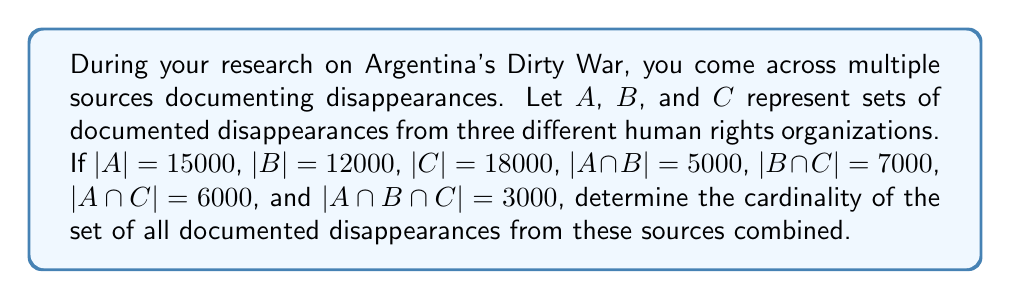What is the answer to this math problem? To solve this problem, we'll use the Inclusion-Exclusion Principle for three sets:

$$|A \cup B \cup C| = |A| + |B| + |C| - |A \cap B| - |B \cap C| - |A \cap C| + |A \cap B \cap C|$$

Let's substitute the given values:

1) $|A| = 15000$
2) $|B| = 12000$
3) $|C| = 18000$
4) $|A \cap B| = 5000$
5) $|B \cap C| = 7000$
6) $|A \cap C| = 6000$
7) $|A \cap B \cap C| = 3000$

Now, let's calculate:

$$\begin{align*}
|A \cup B \cup C| &= 15000 + 12000 + 18000 - 5000 - 7000 - 6000 + 3000 \\
&= 45000 - 18000 + 3000 \\
&= 30000
\end{align*}$$

Therefore, the total number of documented disappearances from all three sources combined is 30,000.
Answer: The cardinality of the set of all documented disappearances from the three sources combined is 30,000. 